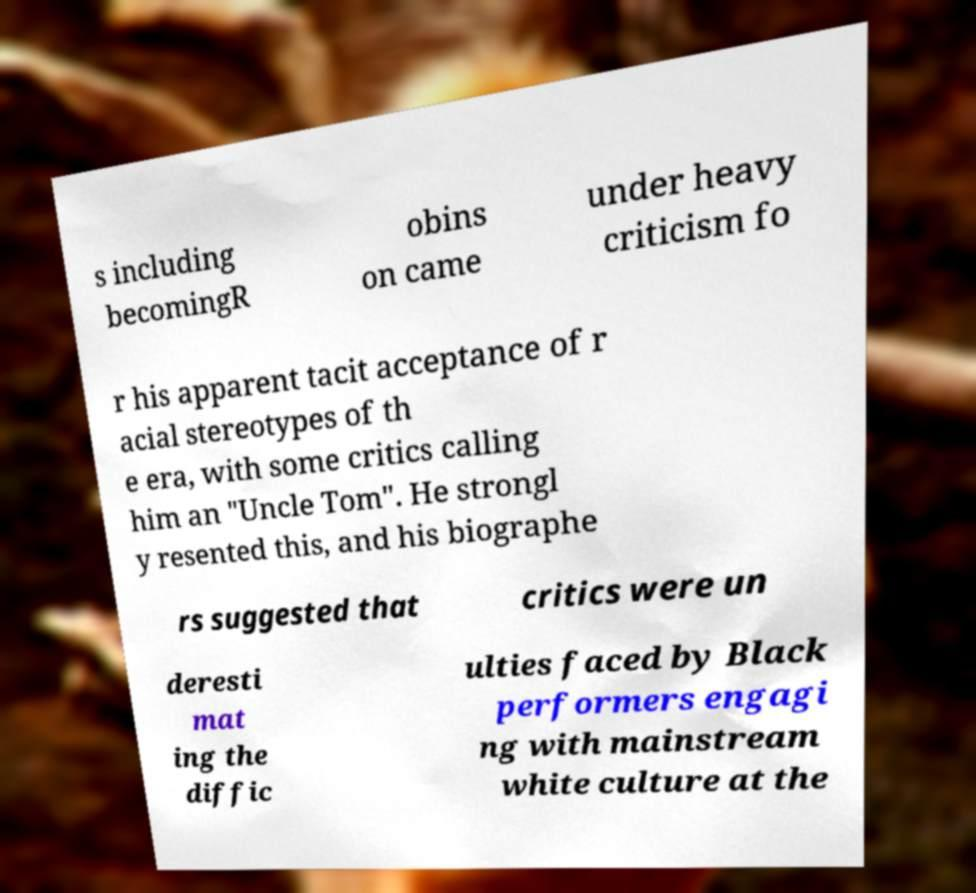Can you accurately transcribe the text from the provided image for me? s including becomingR obins on came under heavy criticism fo r his apparent tacit acceptance of r acial stereotypes of th e era, with some critics calling him an "Uncle Tom". He strongl y resented this, and his biographe rs suggested that critics were un deresti mat ing the diffic ulties faced by Black performers engagi ng with mainstream white culture at the 